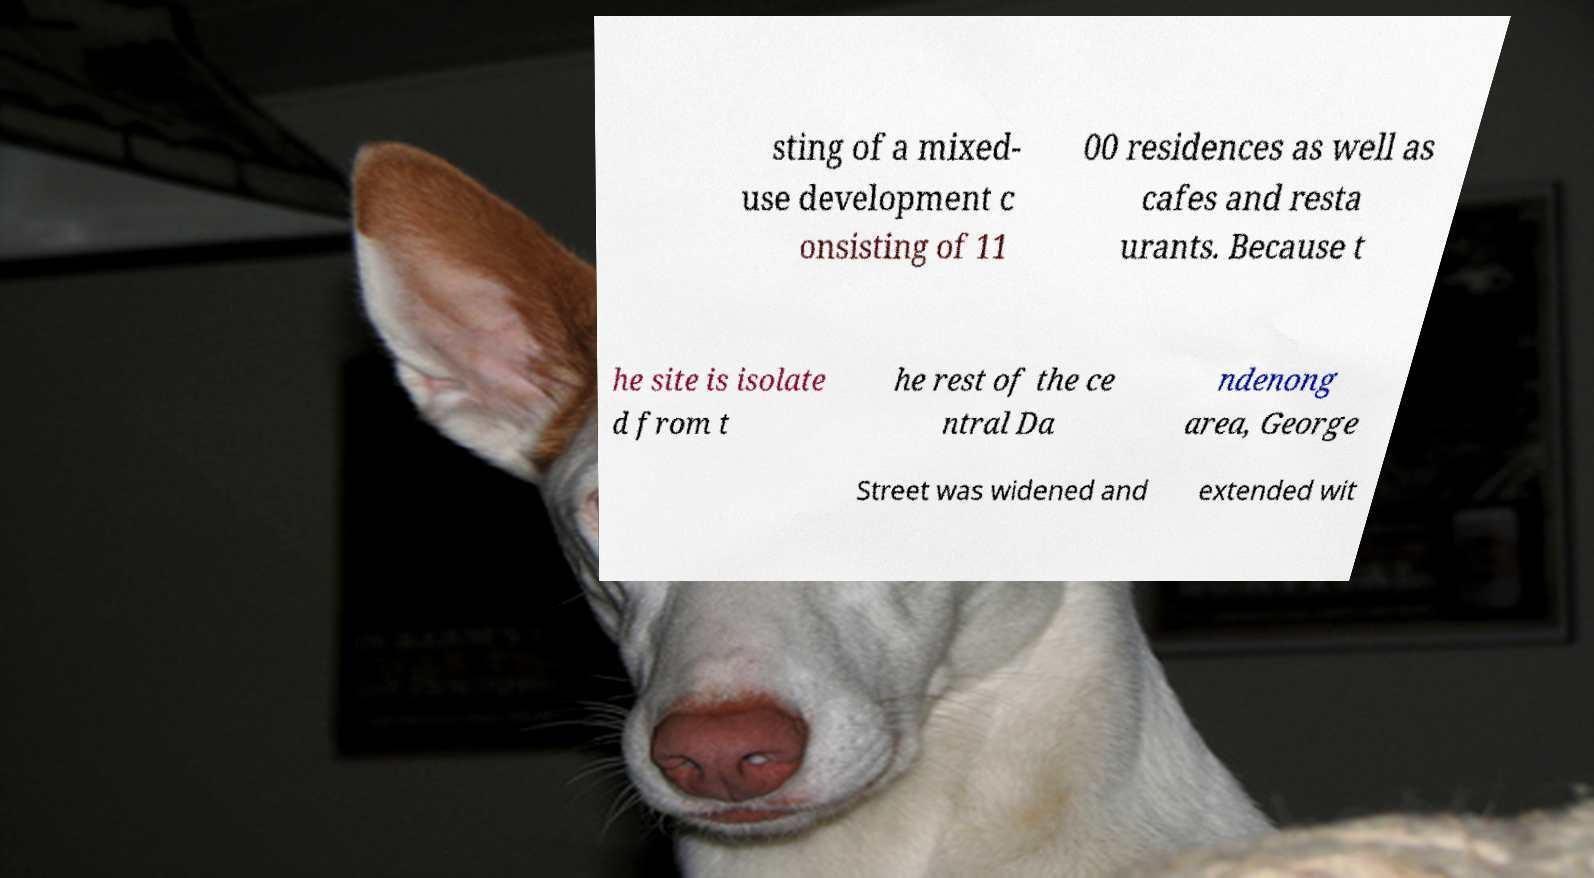Please read and relay the text visible in this image. What does it say? sting of a mixed- use development c onsisting of 11 00 residences as well as cafes and resta urants. Because t he site is isolate d from t he rest of the ce ntral Da ndenong area, George Street was widened and extended wit 